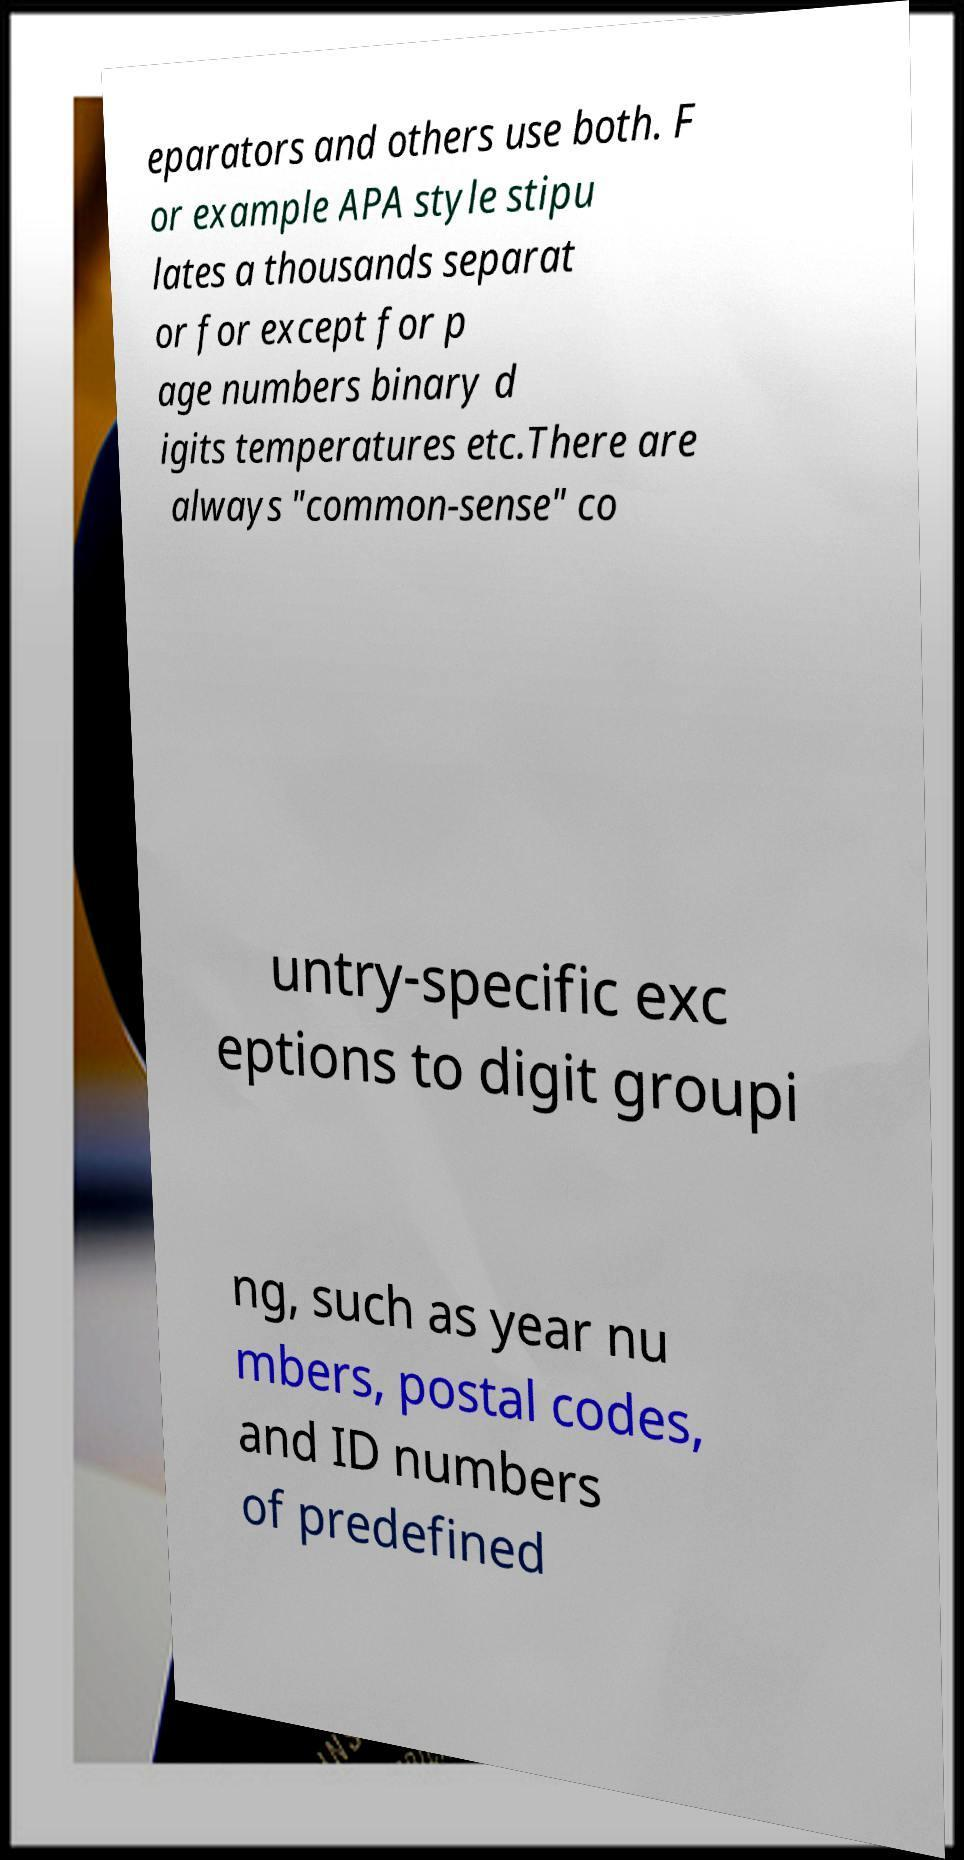I need the written content from this picture converted into text. Can you do that? eparators and others use both. F or example APA style stipu lates a thousands separat or for except for p age numbers binary d igits temperatures etc.There are always "common-sense" co untry-specific exc eptions to digit groupi ng, such as year nu mbers, postal codes, and ID numbers of predefined 